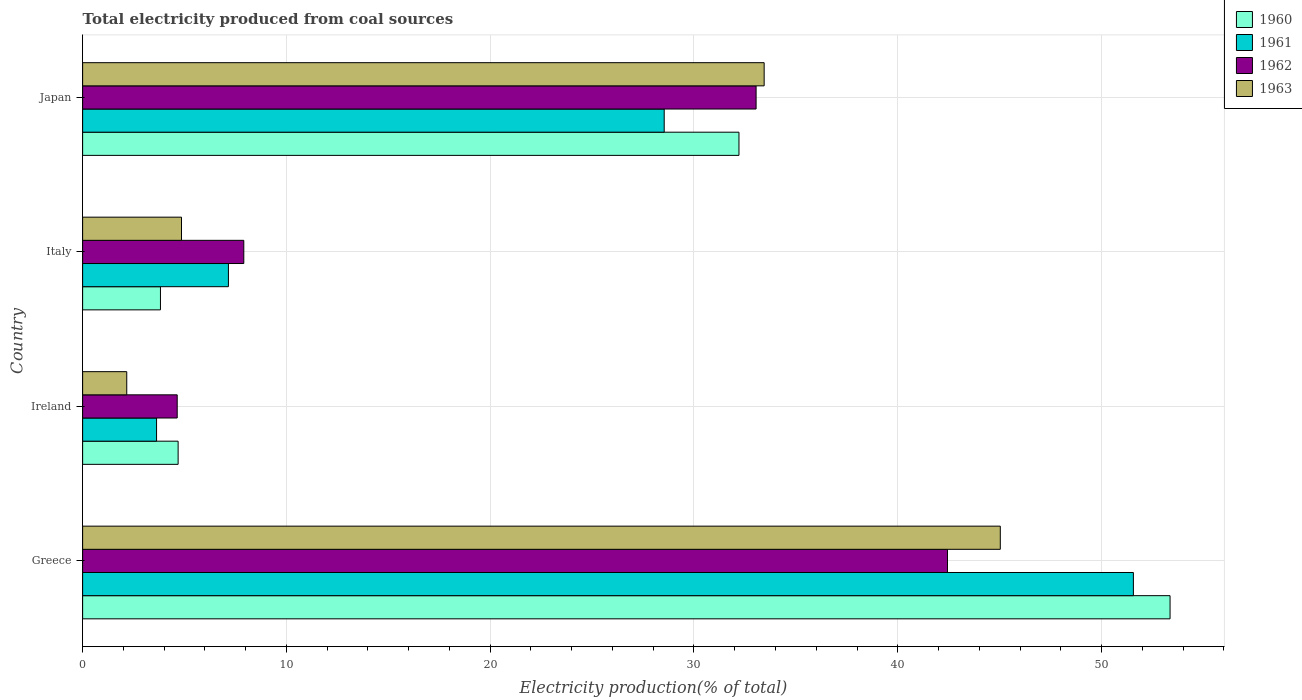How many different coloured bars are there?
Make the answer very short. 4. How many groups of bars are there?
Keep it short and to the point. 4. Are the number of bars per tick equal to the number of legend labels?
Provide a short and direct response. Yes. Are the number of bars on each tick of the Y-axis equal?
Your answer should be very brief. Yes. In how many cases, is the number of bars for a given country not equal to the number of legend labels?
Your answer should be very brief. 0. What is the total electricity produced in 1962 in Greece?
Your answer should be compact. 42.44. Across all countries, what is the maximum total electricity produced in 1962?
Provide a succinct answer. 42.44. Across all countries, what is the minimum total electricity produced in 1963?
Give a very brief answer. 2.16. In which country was the total electricity produced in 1961 maximum?
Provide a short and direct response. Greece. In which country was the total electricity produced in 1961 minimum?
Provide a short and direct response. Ireland. What is the total total electricity produced in 1960 in the graph?
Your response must be concise. 94.07. What is the difference between the total electricity produced in 1960 in Italy and that in Japan?
Provide a succinct answer. -28.39. What is the difference between the total electricity produced in 1960 in Ireland and the total electricity produced in 1962 in Greece?
Your answer should be compact. -37.75. What is the average total electricity produced in 1963 per country?
Make the answer very short. 21.37. What is the difference between the total electricity produced in 1961 and total electricity produced in 1960 in Japan?
Your response must be concise. -3.67. In how many countries, is the total electricity produced in 1961 greater than 14 %?
Offer a very short reply. 2. What is the ratio of the total electricity produced in 1960 in Greece to that in Ireland?
Ensure brevity in your answer.  11.39. What is the difference between the highest and the second highest total electricity produced in 1962?
Ensure brevity in your answer.  9.39. What is the difference between the highest and the lowest total electricity produced in 1960?
Ensure brevity in your answer.  49.54. What does the 1st bar from the top in Greece represents?
Ensure brevity in your answer.  1963. What does the 3rd bar from the bottom in Greece represents?
Offer a very short reply. 1962. Is it the case that in every country, the sum of the total electricity produced in 1961 and total electricity produced in 1960 is greater than the total electricity produced in 1962?
Ensure brevity in your answer.  Yes. How many bars are there?
Provide a succinct answer. 16. Are all the bars in the graph horizontal?
Keep it short and to the point. Yes. What is the difference between two consecutive major ticks on the X-axis?
Keep it short and to the point. 10. Are the values on the major ticks of X-axis written in scientific E-notation?
Your answer should be very brief. No. Does the graph contain grids?
Make the answer very short. Yes. How many legend labels are there?
Offer a terse response. 4. What is the title of the graph?
Ensure brevity in your answer.  Total electricity produced from coal sources. What is the label or title of the X-axis?
Your response must be concise. Electricity production(% of total). What is the label or title of the Y-axis?
Offer a terse response. Country. What is the Electricity production(% of total) of 1960 in Greece?
Provide a succinct answer. 53.36. What is the Electricity production(% of total) of 1961 in Greece?
Provide a short and direct response. 51.56. What is the Electricity production(% of total) in 1962 in Greece?
Your answer should be very brief. 42.44. What is the Electricity production(% of total) in 1963 in Greece?
Ensure brevity in your answer.  45.03. What is the Electricity production(% of total) in 1960 in Ireland?
Offer a very short reply. 4.69. What is the Electricity production(% of total) of 1961 in Ireland?
Give a very brief answer. 3.63. What is the Electricity production(% of total) of 1962 in Ireland?
Give a very brief answer. 4.64. What is the Electricity production(% of total) of 1963 in Ireland?
Provide a succinct answer. 2.16. What is the Electricity production(% of total) in 1960 in Italy?
Your response must be concise. 3.82. What is the Electricity production(% of total) in 1961 in Italy?
Your response must be concise. 7.15. What is the Electricity production(% of total) of 1962 in Italy?
Make the answer very short. 7.91. What is the Electricity production(% of total) of 1963 in Italy?
Provide a short and direct response. 4.85. What is the Electricity production(% of total) of 1960 in Japan?
Ensure brevity in your answer.  32.21. What is the Electricity production(% of total) of 1961 in Japan?
Offer a very short reply. 28.54. What is the Electricity production(% of total) in 1962 in Japan?
Offer a very short reply. 33.05. What is the Electricity production(% of total) in 1963 in Japan?
Make the answer very short. 33.44. Across all countries, what is the maximum Electricity production(% of total) in 1960?
Provide a short and direct response. 53.36. Across all countries, what is the maximum Electricity production(% of total) of 1961?
Your answer should be compact. 51.56. Across all countries, what is the maximum Electricity production(% of total) of 1962?
Give a very brief answer. 42.44. Across all countries, what is the maximum Electricity production(% of total) of 1963?
Make the answer very short. 45.03. Across all countries, what is the minimum Electricity production(% of total) of 1960?
Provide a short and direct response. 3.82. Across all countries, what is the minimum Electricity production(% of total) of 1961?
Provide a short and direct response. 3.63. Across all countries, what is the minimum Electricity production(% of total) in 1962?
Make the answer very short. 4.64. Across all countries, what is the minimum Electricity production(% of total) of 1963?
Provide a short and direct response. 2.16. What is the total Electricity production(% of total) in 1960 in the graph?
Your answer should be compact. 94.07. What is the total Electricity production(% of total) in 1961 in the graph?
Make the answer very short. 90.88. What is the total Electricity production(% of total) in 1962 in the graph?
Give a very brief answer. 88.04. What is the total Electricity production(% of total) of 1963 in the graph?
Keep it short and to the point. 85.49. What is the difference between the Electricity production(% of total) in 1960 in Greece and that in Ireland?
Offer a very short reply. 48.68. What is the difference between the Electricity production(% of total) in 1961 in Greece and that in Ireland?
Your answer should be compact. 47.93. What is the difference between the Electricity production(% of total) in 1962 in Greece and that in Ireland?
Your response must be concise. 37.8. What is the difference between the Electricity production(% of total) in 1963 in Greece and that in Ireland?
Keep it short and to the point. 42.87. What is the difference between the Electricity production(% of total) in 1960 in Greece and that in Italy?
Give a very brief answer. 49.54. What is the difference between the Electricity production(% of total) of 1961 in Greece and that in Italy?
Keep it short and to the point. 44.41. What is the difference between the Electricity production(% of total) of 1962 in Greece and that in Italy?
Provide a short and direct response. 34.53. What is the difference between the Electricity production(% of total) of 1963 in Greece and that in Italy?
Provide a succinct answer. 40.18. What is the difference between the Electricity production(% of total) in 1960 in Greece and that in Japan?
Give a very brief answer. 21.15. What is the difference between the Electricity production(% of total) of 1961 in Greece and that in Japan?
Provide a succinct answer. 23.02. What is the difference between the Electricity production(% of total) in 1962 in Greece and that in Japan?
Give a very brief answer. 9.39. What is the difference between the Electricity production(% of total) of 1963 in Greece and that in Japan?
Keep it short and to the point. 11.59. What is the difference between the Electricity production(% of total) in 1960 in Ireland and that in Italy?
Your response must be concise. 0.87. What is the difference between the Electricity production(% of total) of 1961 in Ireland and that in Italy?
Provide a short and direct response. -3.53. What is the difference between the Electricity production(% of total) of 1962 in Ireland and that in Italy?
Make the answer very short. -3.27. What is the difference between the Electricity production(% of total) of 1963 in Ireland and that in Italy?
Your response must be concise. -2.69. What is the difference between the Electricity production(% of total) in 1960 in Ireland and that in Japan?
Provide a short and direct response. -27.52. What is the difference between the Electricity production(% of total) in 1961 in Ireland and that in Japan?
Provide a succinct answer. -24.91. What is the difference between the Electricity production(% of total) of 1962 in Ireland and that in Japan?
Offer a very short reply. -28.41. What is the difference between the Electricity production(% of total) in 1963 in Ireland and that in Japan?
Provide a short and direct response. -31.28. What is the difference between the Electricity production(% of total) of 1960 in Italy and that in Japan?
Give a very brief answer. -28.39. What is the difference between the Electricity production(% of total) in 1961 in Italy and that in Japan?
Your response must be concise. -21.38. What is the difference between the Electricity production(% of total) of 1962 in Italy and that in Japan?
Your answer should be compact. -25.14. What is the difference between the Electricity production(% of total) in 1963 in Italy and that in Japan?
Give a very brief answer. -28.59. What is the difference between the Electricity production(% of total) in 1960 in Greece and the Electricity production(% of total) in 1961 in Ireland?
Ensure brevity in your answer.  49.73. What is the difference between the Electricity production(% of total) of 1960 in Greece and the Electricity production(% of total) of 1962 in Ireland?
Your response must be concise. 48.72. What is the difference between the Electricity production(% of total) of 1960 in Greece and the Electricity production(% of total) of 1963 in Ireland?
Your response must be concise. 51.2. What is the difference between the Electricity production(% of total) in 1961 in Greece and the Electricity production(% of total) in 1962 in Ireland?
Your answer should be compact. 46.92. What is the difference between the Electricity production(% of total) in 1961 in Greece and the Electricity production(% of total) in 1963 in Ireland?
Offer a terse response. 49.4. What is the difference between the Electricity production(% of total) in 1962 in Greece and the Electricity production(% of total) in 1963 in Ireland?
Your response must be concise. 40.27. What is the difference between the Electricity production(% of total) of 1960 in Greece and the Electricity production(% of total) of 1961 in Italy?
Your answer should be very brief. 46.21. What is the difference between the Electricity production(% of total) of 1960 in Greece and the Electricity production(% of total) of 1962 in Italy?
Provide a succinct answer. 45.45. What is the difference between the Electricity production(% of total) of 1960 in Greece and the Electricity production(% of total) of 1963 in Italy?
Provide a succinct answer. 48.51. What is the difference between the Electricity production(% of total) in 1961 in Greece and the Electricity production(% of total) in 1962 in Italy?
Your response must be concise. 43.65. What is the difference between the Electricity production(% of total) of 1961 in Greece and the Electricity production(% of total) of 1963 in Italy?
Keep it short and to the point. 46.71. What is the difference between the Electricity production(% of total) of 1962 in Greece and the Electricity production(% of total) of 1963 in Italy?
Ensure brevity in your answer.  37.59. What is the difference between the Electricity production(% of total) in 1960 in Greece and the Electricity production(% of total) in 1961 in Japan?
Make the answer very short. 24.82. What is the difference between the Electricity production(% of total) in 1960 in Greece and the Electricity production(% of total) in 1962 in Japan?
Give a very brief answer. 20.31. What is the difference between the Electricity production(% of total) in 1960 in Greece and the Electricity production(% of total) in 1963 in Japan?
Ensure brevity in your answer.  19.92. What is the difference between the Electricity production(% of total) in 1961 in Greece and the Electricity production(% of total) in 1962 in Japan?
Ensure brevity in your answer.  18.51. What is the difference between the Electricity production(% of total) of 1961 in Greece and the Electricity production(% of total) of 1963 in Japan?
Offer a terse response. 18.12. What is the difference between the Electricity production(% of total) of 1962 in Greece and the Electricity production(% of total) of 1963 in Japan?
Offer a terse response. 9. What is the difference between the Electricity production(% of total) in 1960 in Ireland and the Electricity production(% of total) in 1961 in Italy?
Your response must be concise. -2.47. What is the difference between the Electricity production(% of total) of 1960 in Ireland and the Electricity production(% of total) of 1962 in Italy?
Your answer should be very brief. -3.22. What is the difference between the Electricity production(% of total) in 1960 in Ireland and the Electricity production(% of total) in 1963 in Italy?
Offer a terse response. -0.17. What is the difference between the Electricity production(% of total) in 1961 in Ireland and the Electricity production(% of total) in 1962 in Italy?
Ensure brevity in your answer.  -4.28. What is the difference between the Electricity production(% of total) in 1961 in Ireland and the Electricity production(% of total) in 1963 in Italy?
Your answer should be compact. -1.22. What is the difference between the Electricity production(% of total) of 1962 in Ireland and the Electricity production(% of total) of 1963 in Italy?
Your answer should be compact. -0.21. What is the difference between the Electricity production(% of total) of 1960 in Ireland and the Electricity production(% of total) of 1961 in Japan?
Make the answer very short. -23.85. What is the difference between the Electricity production(% of total) in 1960 in Ireland and the Electricity production(% of total) in 1962 in Japan?
Make the answer very short. -28.36. What is the difference between the Electricity production(% of total) in 1960 in Ireland and the Electricity production(% of total) in 1963 in Japan?
Offer a very short reply. -28.76. What is the difference between the Electricity production(% of total) in 1961 in Ireland and the Electricity production(% of total) in 1962 in Japan?
Ensure brevity in your answer.  -29.42. What is the difference between the Electricity production(% of total) of 1961 in Ireland and the Electricity production(% of total) of 1963 in Japan?
Ensure brevity in your answer.  -29.82. What is the difference between the Electricity production(% of total) of 1962 in Ireland and the Electricity production(% of total) of 1963 in Japan?
Your answer should be compact. -28.8. What is the difference between the Electricity production(% of total) in 1960 in Italy and the Electricity production(% of total) in 1961 in Japan?
Give a very brief answer. -24.72. What is the difference between the Electricity production(% of total) of 1960 in Italy and the Electricity production(% of total) of 1962 in Japan?
Provide a short and direct response. -29.23. What is the difference between the Electricity production(% of total) of 1960 in Italy and the Electricity production(% of total) of 1963 in Japan?
Ensure brevity in your answer.  -29.63. What is the difference between the Electricity production(% of total) of 1961 in Italy and the Electricity production(% of total) of 1962 in Japan?
Provide a succinct answer. -25.89. What is the difference between the Electricity production(% of total) in 1961 in Italy and the Electricity production(% of total) in 1963 in Japan?
Your answer should be compact. -26.29. What is the difference between the Electricity production(% of total) of 1962 in Italy and the Electricity production(% of total) of 1963 in Japan?
Keep it short and to the point. -25.53. What is the average Electricity production(% of total) in 1960 per country?
Provide a succinct answer. 23.52. What is the average Electricity production(% of total) in 1961 per country?
Offer a very short reply. 22.72. What is the average Electricity production(% of total) in 1962 per country?
Offer a terse response. 22.01. What is the average Electricity production(% of total) in 1963 per country?
Your response must be concise. 21.37. What is the difference between the Electricity production(% of total) of 1960 and Electricity production(% of total) of 1961 in Greece?
Keep it short and to the point. 1.8. What is the difference between the Electricity production(% of total) in 1960 and Electricity production(% of total) in 1962 in Greece?
Your answer should be very brief. 10.92. What is the difference between the Electricity production(% of total) of 1960 and Electricity production(% of total) of 1963 in Greece?
Your response must be concise. 8.33. What is the difference between the Electricity production(% of total) in 1961 and Electricity production(% of total) in 1962 in Greece?
Your response must be concise. 9.12. What is the difference between the Electricity production(% of total) of 1961 and Electricity production(% of total) of 1963 in Greece?
Give a very brief answer. 6.53. What is the difference between the Electricity production(% of total) in 1962 and Electricity production(% of total) in 1963 in Greece?
Your response must be concise. -2.59. What is the difference between the Electricity production(% of total) of 1960 and Electricity production(% of total) of 1961 in Ireland?
Make the answer very short. 1.06. What is the difference between the Electricity production(% of total) of 1960 and Electricity production(% of total) of 1962 in Ireland?
Offer a terse response. 0.05. What is the difference between the Electricity production(% of total) in 1960 and Electricity production(% of total) in 1963 in Ireland?
Offer a very short reply. 2.52. What is the difference between the Electricity production(% of total) of 1961 and Electricity production(% of total) of 1962 in Ireland?
Offer a terse response. -1.01. What is the difference between the Electricity production(% of total) in 1961 and Electricity production(% of total) in 1963 in Ireland?
Your response must be concise. 1.46. What is the difference between the Electricity production(% of total) in 1962 and Electricity production(% of total) in 1963 in Ireland?
Provide a short and direct response. 2.48. What is the difference between the Electricity production(% of total) of 1960 and Electricity production(% of total) of 1961 in Italy?
Provide a short and direct response. -3.34. What is the difference between the Electricity production(% of total) in 1960 and Electricity production(% of total) in 1962 in Italy?
Your answer should be compact. -4.09. What is the difference between the Electricity production(% of total) of 1960 and Electricity production(% of total) of 1963 in Italy?
Ensure brevity in your answer.  -1.03. What is the difference between the Electricity production(% of total) of 1961 and Electricity production(% of total) of 1962 in Italy?
Make the answer very short. -0.75. What is the difference between the Electricity production(% of total) of 1961 and Electricity production(% of total) of 1963 in Italy?
Your answer should be compact. 2.3. What is the difference between the Electricity production(% of total) of 1962 and Electricity production(% of total) of 1963 in Italy?
Make the answer very short. 3.06. What is the difference between the Electricity production(% of total) of 1960 and Electricity production(% of total) of 1961 in Japan?
Your response must be concise. 3.67. What is the difference between the Electricity production(% of total) of 1960 and Electricity production(% of total) of 1962 in Japan?
Make the answer very short. -0.84. What is the difference between the Electricity production(% of total) of 1960 and Electricity production(% of total) of 1963 in Japan?
Your answer should be compact. -1.24. What is the difference between the Electricity production(% of total) of 1961 and Electricity production(% of total) of 1962 in Japan?
Give a very brief answer. -4.51. What is the difference between the Electricity production(% of total) of 1961 and Electricity production(% of total) of 1963 in Japan?
Offer a terse response. -4.9. What is the difference between the Electricity production(% of total) in 1962 and Electricity production(% of total) in 1963 in Japan?
Provide a short and direct response. -0.4. What is the ratio of the Electricity production(% of total) in 1960 in Greece to that in Ireland?
Your answer should be very brief. 11.39. What is the ratio of the Electricity production(% of total) in 1961 in Greece to that in Ireland?
Offer a very short reply. 14.21. What is the ratio of the Electricity production(% of total) of 1962 in Greece to that in Ireland?
Offer a very short reply. 9.14. What is the ratio of the Electricity production(% of total) in 1963 in Greece to that in Ireland?
Keep it short and to the point. 20.8. What is the ratio of the Electricity production(% of total) of 1960 in Greece to that in Italy?
Keep it short and to the point. 13.97. What is the ratio of the Electricity production(% of total) of 1961 in Greece to that in Italy?
Offer a terse response. 7.21. What is the ratio of the Electricity production(% of total) in 1962 in Greece to that in Italy?
Make the answer very short. 5.37. What is the ratio of the Electricity production(% of total) in 1963 in Greece to that in Italy?
Make the answer very short. 9.28. What is the ratio of the Electricity production(% of total) of 1960 in Greece to that in Japan?
Make the answer very short. 1.66. What is the ratio of the Electricity production(% of total) of 1961 in Greece to that in Japan?
Your answer should be compact. 1.81. What is the ratio of the Electricity production(% of total) of 1962 in Greece to that in Japan?
Provide a short and direct response. 1.28. What is the ratio of the Electricity production(% of total) of 1963 in Greece to that in Japan?
Make the answer very short. 1.35. What is the ratio of the Electricity production(% of total) in 1960 in Ireland to that in Italy?
Your answer should be very brief. 1.23. What is the ratio of the Electricity production(% of total) in 1961 in Ireland to that in Italy?
Provide a succinct answer. 0.51. What is the ratio of the Electricity production(% of total) in 1962 in Ireland to that in Italy?
Offer a very short reply. 0.59. What is the ratio of the Electricity production(% of total) in 1963 in Ireland to that in Italy?
Keep it short and to the point. 0.45. What is the ratio of the Electricity production(% of total) of 1960 in Ireland to that in Japan?
Ensure brevity in your answer.  0.15. What is the ratio of the Electricity production(% of total) of 1961 in Ireland to that in Japan?
Keep it short and to the point. 0.13. What is the ratio of the Electricity production(% of total) in 1962 in Ireland to that in Japan?
Your answer should be compact. 0.14. What is the ratio of the Electricity production(% of total) of 1963 in Ireland to that in Japan?
Your response must be concise. 0.06. What is the ratio of the Electricity production(% of total) in 1960 in Italy to that in Japan?
Your answer should be very brief. 0.12. What is the ratio of the Electricity production(% of total) in 1961 in Italy to that in Japan?
Your answer should be compact. 0.25. What is the ratio of the Electricity production(% of total) in 1962 in Italy to that in Japan?
Your answer should be very brief. 0.24. What is the ratio of the Electricity production(% of total) of 1963 in Italy to that in Japan?
Your answer should be very brief. 0.15. What is the difference between the highest and the second highest Electricity production(% of total) in 1960?
Your answer should be very brief. 21.15. What is the difference between the highest and the second highest Electricity production(% of total) of 1961?
Keep it short and to the point. 23.02. What is the difference between the highest and the second highest Electricity production(% of total) in 1962?
Your answer should be very brief. 9.39. What is the difference between the highest and the second highest Electricity production(% of total) of 1963?
Your answer should be compact. 11.59. What is the difference between the highest and the lowest Electricity production(% of total) of 1960?
Provide a succinct answer. 49.54. What is the difference between the highest and the lowest Electricity production(% of total) of 1961?
Your answer should be compact. 47.93. What is the difference between the highest and the lowest Electricity production(% of total) of 1962?
Keep it short and to the point. 37.8. What is the difference between the highest and the lowest Electricity production(% of total) of 1963?
Make the answer very short. 42.87. 